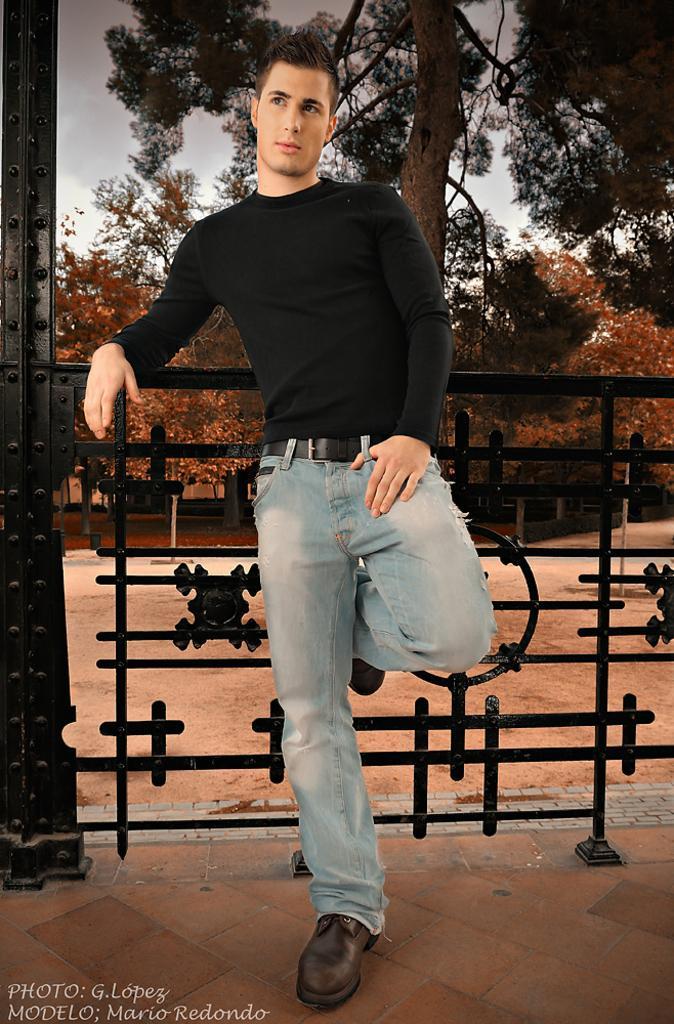Can you describe this image briefly? In this image there is the sky, there are trees, there is a person standing, there are trees truncated towards the right of the image, there is an object truncated towards the left of the image, there is an object behind the person, there is text towards the bottom of the image. 